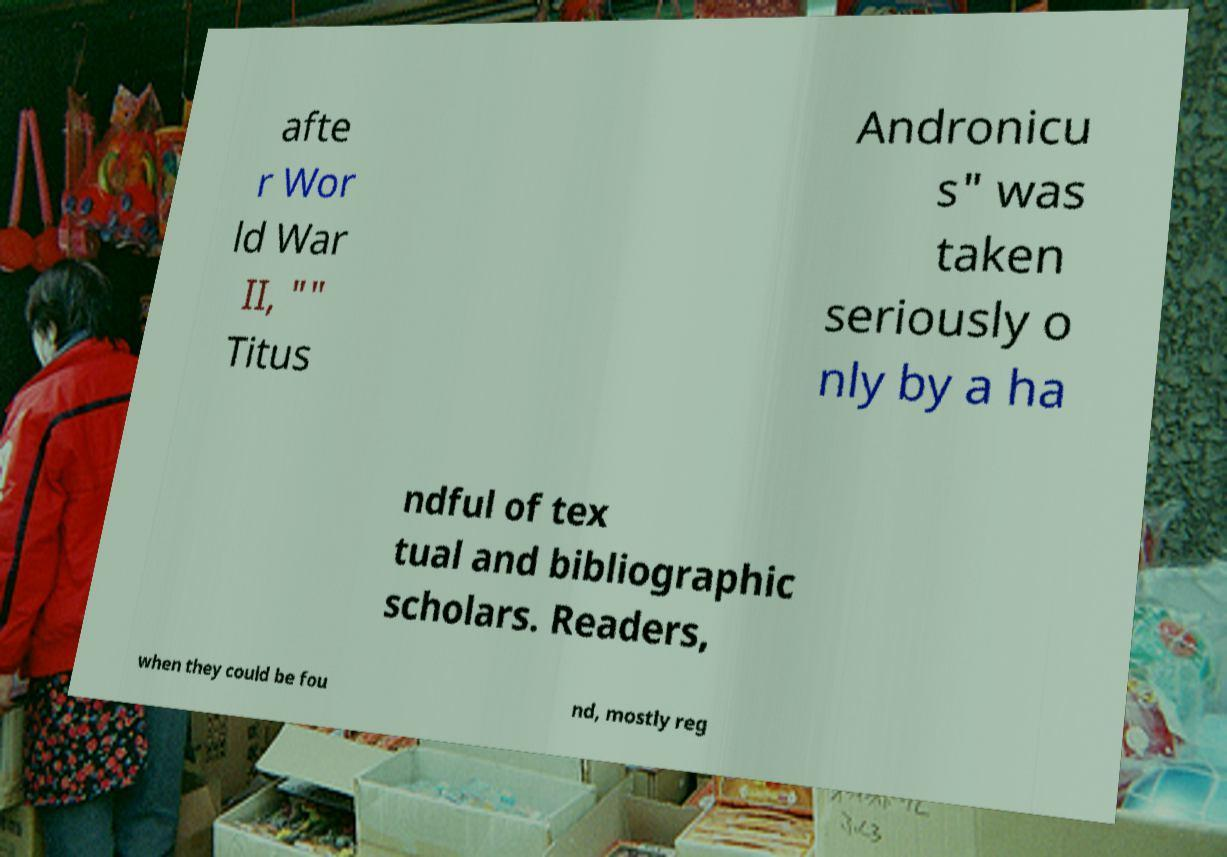Please identify and transcribe the text found in this image. afte r Wor ld War II, "" Titus Andronicu s" was taken seriously o nly by a ha ndful of tex tual and bibliographic scholars. Readers, when they could be fou nd, mostly reg 